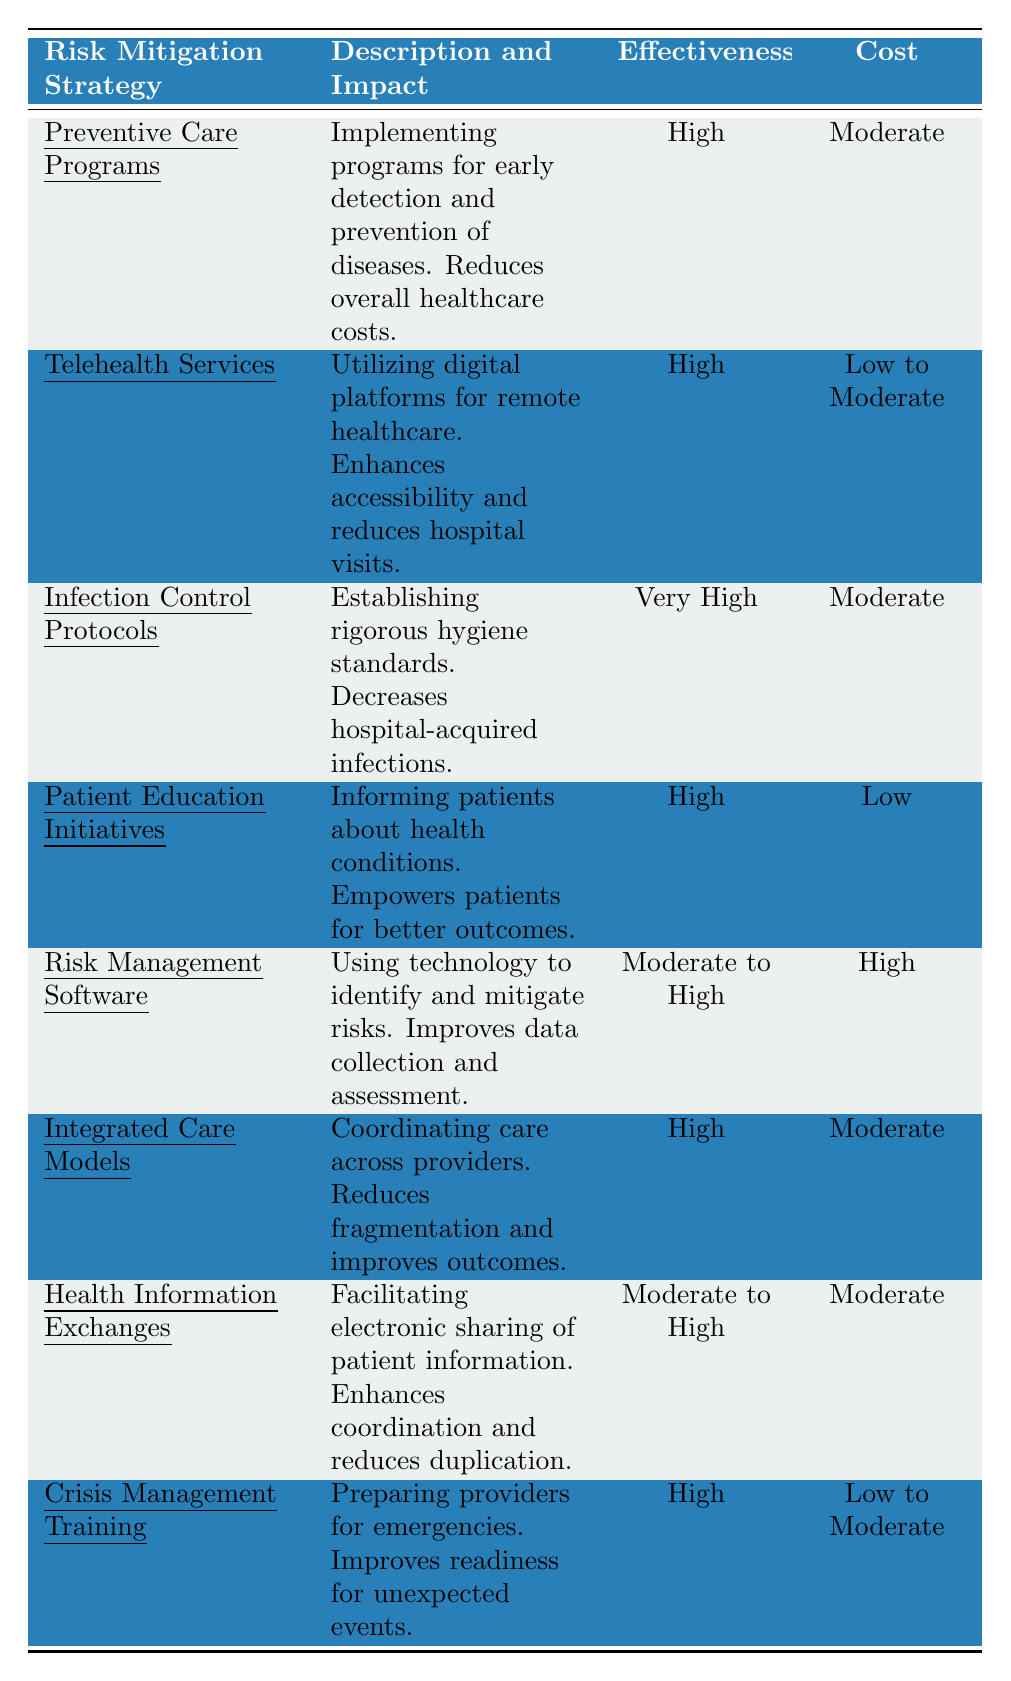What is the effectiveness rating of Infection Control Protocols? The table states that the effectiveness of Infection Control Protocols is categorized as "Very High."
Answer: Very High What is the cost associated with Patient Education Initiatives? According to the table, Patient Education Initiatives have a cost categorized as "Low."
Answer: Low Which strategy has the lowest cost? The strategies listed are compared, and Patient Education Initiatives have the lowest cost classification of "Low."
Answer: Patient Education Initiatives Which two strategies have a high effectiveness rating? The strategies with a high effectiveness rating include Preventive Care Programs, Telehealth Services, Patient Education Initiatives, Integrated Care Models, and Crisis Management Training.
Answer: Preventive Care Programs and Telehealth Services Are all strategies in the table considered effective? The table categorizes effectiveness into different levels for each strategy, confirming that not all strategies are rated equally. Therefore, it is not true that all strategies are effective.
Answer: No What is the combined cost of Crisis Management Training and Telehealth Services? Crisis Management Training is Low to Moderate, and Telehealth Services is Low to Moderate. Their combined cost remains within the "Low to Moderate" range since specific numbers are not provided.
Answer: Low to Moderate Which strategy demonstrates the highest effectiveness and moderate cost? The table indicates that Infection Control Protocols fulfill the criteria of both being rated "Very High" for effectiveness and categorized as having a "Moderate" cost.
Answer: Infection Control Protocols How many strategies have a cost categorized as high? The table lists one strategy, which is Risk Management Software, as having a cost categorized as "High."
Answer: 1 What is the relationship between effectiveness and cost for Integrated Care Models and Health Information Exchanges? Integrated Care Models are rated "High" for effectiveness with a "Moderate" cost, while Health Information Exchanges show a "Moderate to High" effectiveness with a "Moderate" cost. Both have a moderate cost, but their effectiveness differs slightly.
Answer: Moderate cost; differing effectiveness If a healthcare facility wants to focus on strategies with low cost and high effectiveness, which ones should they prioritize based on this table? The suitable strategies are Patient Education Initiatives and Telehealth Services since they both possess high effectiveness ratings and low to moderate costs.
Answer: Patient Education Initiatives and Telehealth Services 